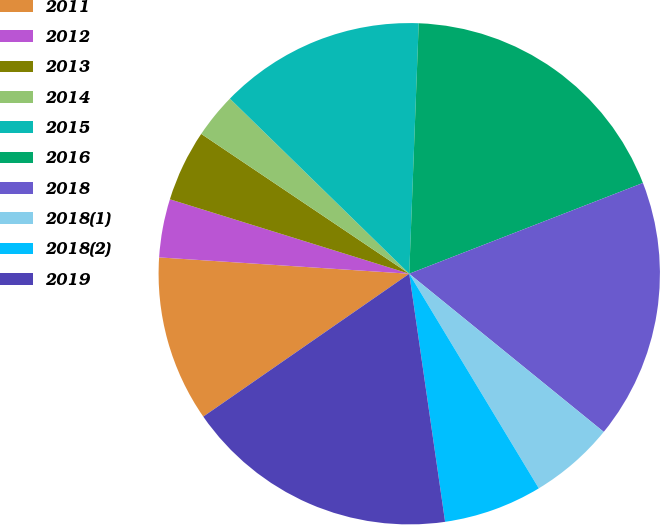Convert chart. <chart><loc_0><loc_0><loc_500><loc_500><pie_chart><fcel>2011<fcel>2012<fcel>2013<fcel>2014<fcel>2015<fcel>2016<fcel>2018<fcel>2018(1)<fcel>2018(2)<fcel>2019<nl><fcel>10.69%<fcel>3.76%<fcel>4.62%<fcel>2.89%<fcel>13.29%<fcel>18.5%<fcel>16.76%<fcel>5.49%<fcel>6.36%<fcel>17.63%<nl></chart> 